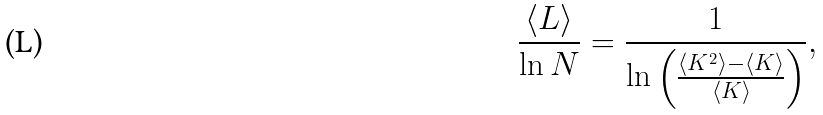Convert formula to latex. <formula><loc_0><loc_0><loc_500><loc_500>\frac { \langle L \rangle } { \ln N } = \frac { 1 } { \ln \left ( \frac { \langle K ^ { 2 } \rangle - \langle K \rangle } { \langle K \rangle } \right ) } ,</formula> 